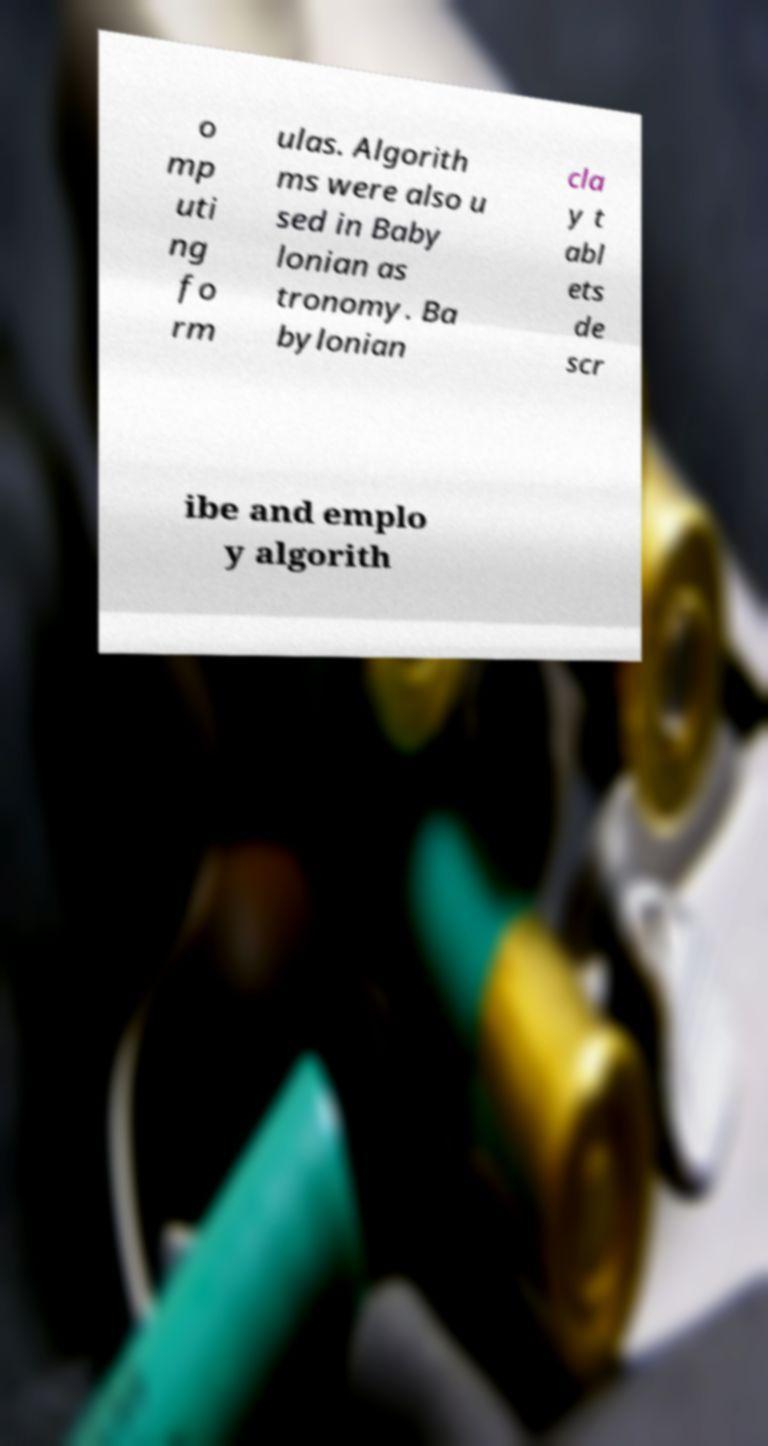For documentation purposes, I need the text within this image transcribed. Could you provide that? o mp uti ng fo rm ulas. Algorith ms were also u sed in Baby lonian as tronomy. Ba bylonian cla y t abl ets de scr ibe and emplo y algorith 